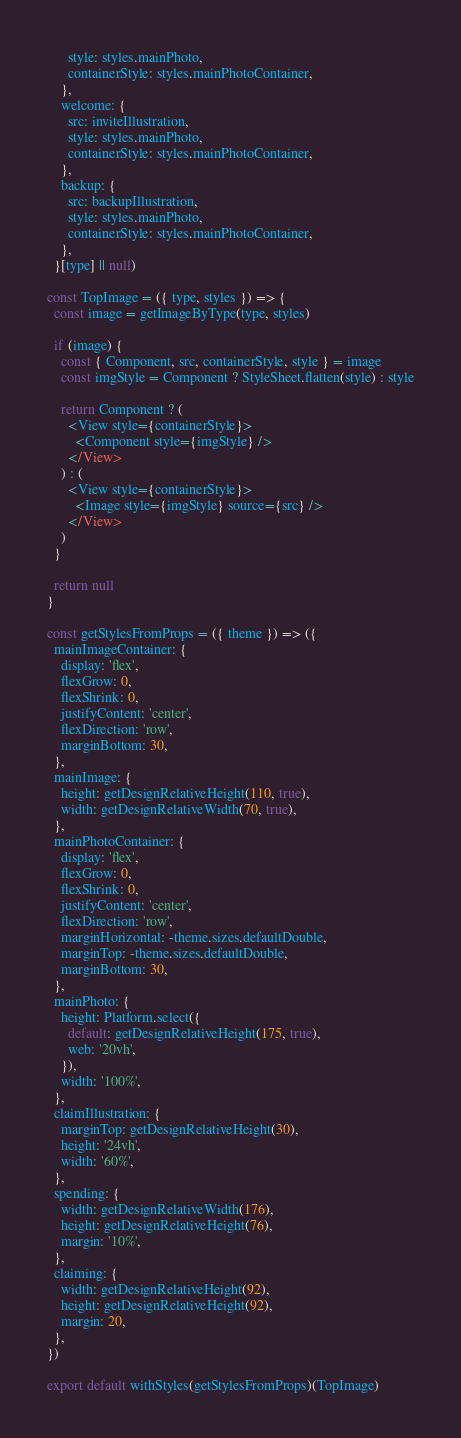<code> <loc_0><loc_0><loc_500><loc_500><_JavaScript_>      style: styles.mainPhoto,
      containerStyle: styles.mainPhotoContainer,
    },
    welcome: {
      src: inviteIllustration,
      style: styles.mainPhoto,
      containerStyle: styles.mainPhotoContainer,
    },
    backup: {
      src: backupIllustration,
      style: styles.mainPhoto,
      containerStyle: styles.mainPhotoContainer,
    },
  }[type] || null)

const TopImage = ({ type, styles }) => {
  const image = getImageByType(type, styles)

  if (image) {
    const { Component, src, containerStyle, style } = image
    const imgStyle = Component ? StyleSheet.flatten(style) : style

    return Component ? (
      <View style={containerStyle}>
        <Component style={imgStyle} />
      </View>
    ) : (
      <View style={containerStyle}>
        <Image style={imgStyle} source={src} />
      </View>
    )
  }

  return null
}

const getStylesFromProps = ({ theme }) => ({
  mainImageContainer: {
    display: 'flex',
    flexGrow: 0,
    flexShrink: 0,
    justifyContent: 'center',
    flexDirection: 'row',
    marginBottom: 30,
  },
  mainImage: {
    height: getDesignRelativeHeight(110, true),
    width: getDesignRelativeWidth(70, true),
  },
  mainPhotoContainer: {
    display: 'flex',
    flexGrow: 0,
    flexShrink: 0,
    justifyContent: 'center',
    flexDirection: 'row',
    marginHorizontal: -theme.sizes.defaultDouble,
    marginTop: -theme.sizes.defaultDouble,
    marginBottom: 30,
  },
  mainPhoto: {
    height: Platform.select({
      default: getDesignRelativeHeight(175, true),
      web: '20vh',
    }),
    width: '100%',
  },
  claimIllustration: {
    marginTop: getDesignRelativeHeight(30),
    height: '24vh',
    width: '60%',
  },
  spending: {
    width: getDesignRelativeWidth(176),
    height: getDesignRelativeHeight(76),
    margin: '10%',
  },
  claiming: {
    width: getDesignRelativeHeight(92),
    height: getDesignRelativeHeight(92),
    margin: 20,
  },
})

export default withStyles(getStylesFromProps)(TopImage)
</code> 